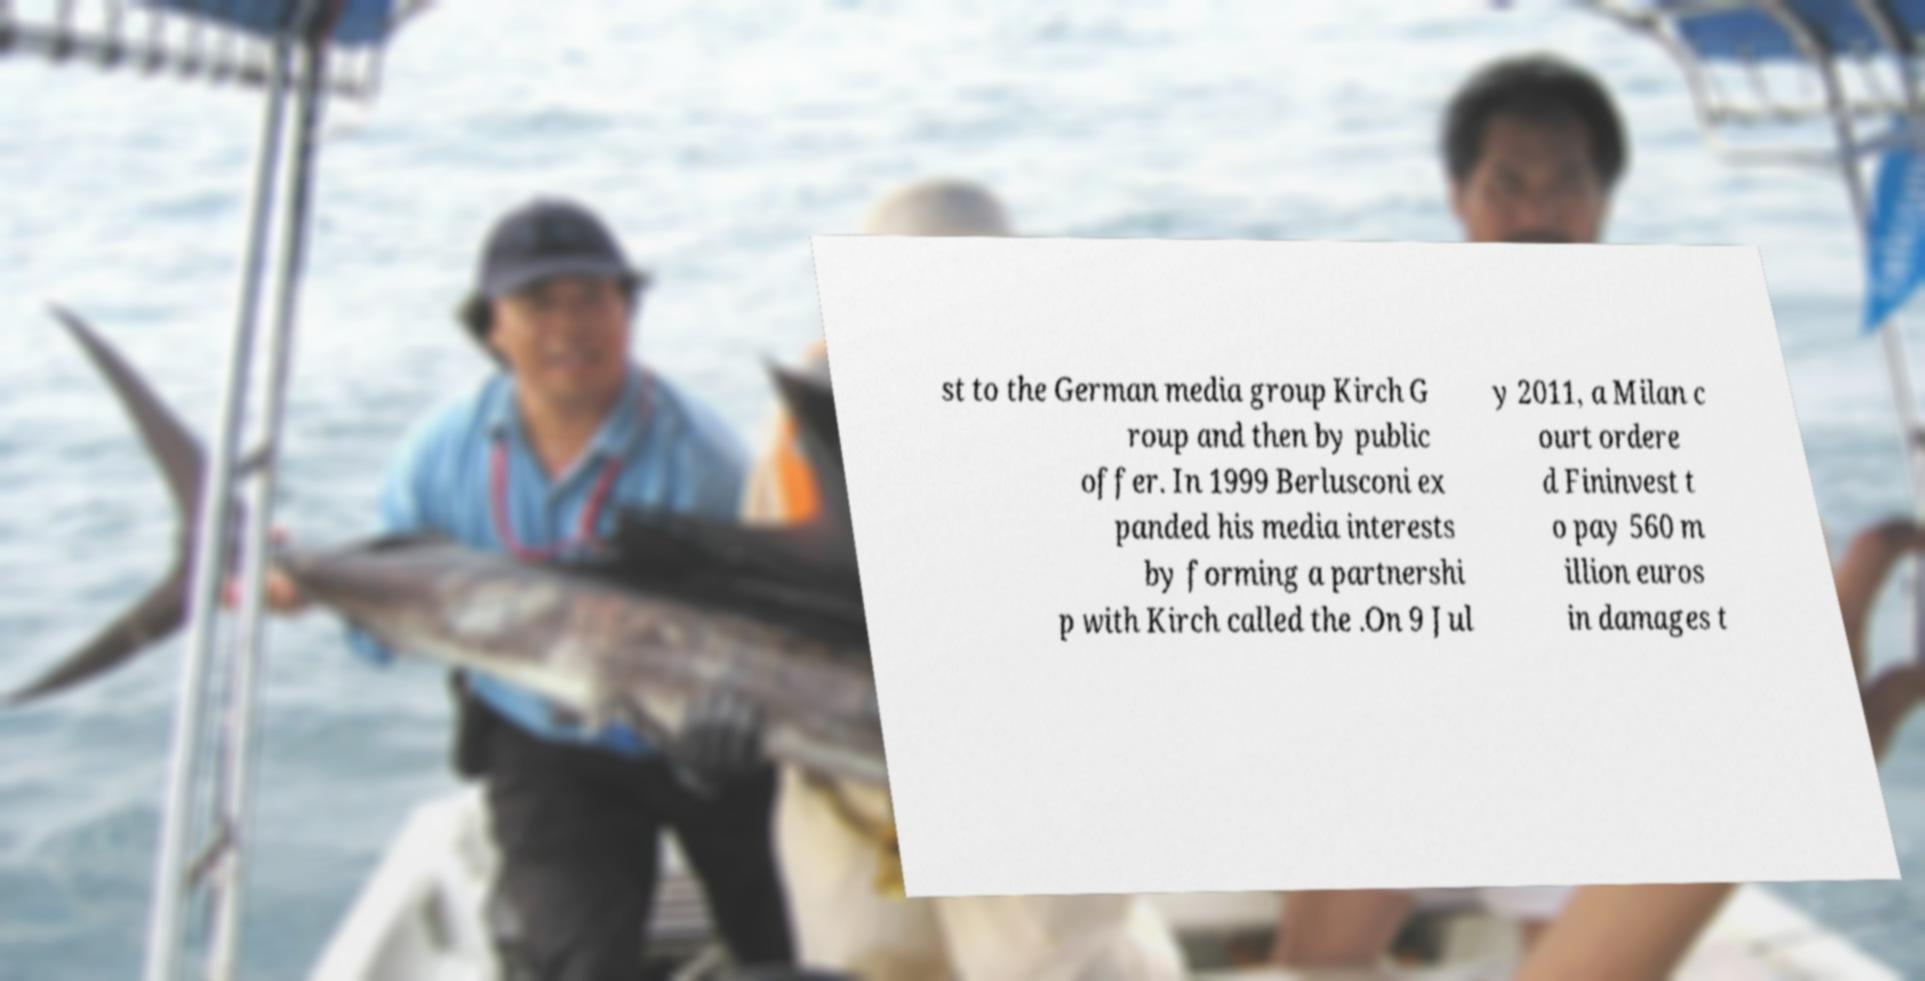Can you accurately transcribe the text from the provided image for me? st to the German media group Kirch G roup and then by public offer. In 1999 Berlusconi ex panded his media interests by forming a partnershi p with Kirch called the .On 9 Jul y 2011, a Milan c ourt ordere d Fininvest t o pay 560 m illion euros in damages t 